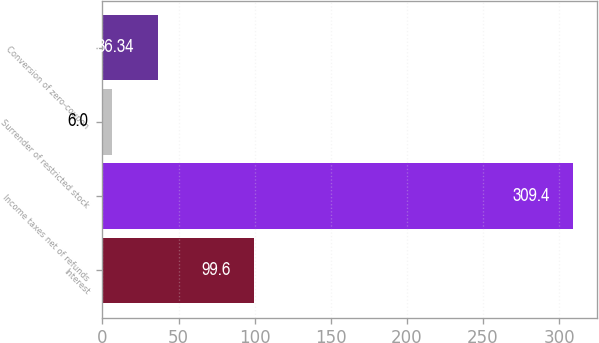<chart> <loc_0><loc_0><loc_500><loc_500><bar_chart><fcel>Interest<fcel>Income taxes net of refunds<fcel>Surrender of restricted stock<fcel>Conversion of zero-coupon<nl><fcel>99.6<fcel>309.4<fcel>6<fcel>36.34<nl></chart> 